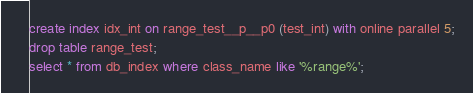<code> <loc_0><loc_0><loc_500><loc_500><_SQL_>create index idx_int on range_test__p__p0 (test_int) with online parallel 5;
drop table range_test;
select * from db_index where class_name like '%range%';
</code> 